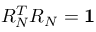<formula> <loc_0><loc_0><loc_500><loc_500>R _ { N } ^ { T } R _ { N } = 1</formula> 